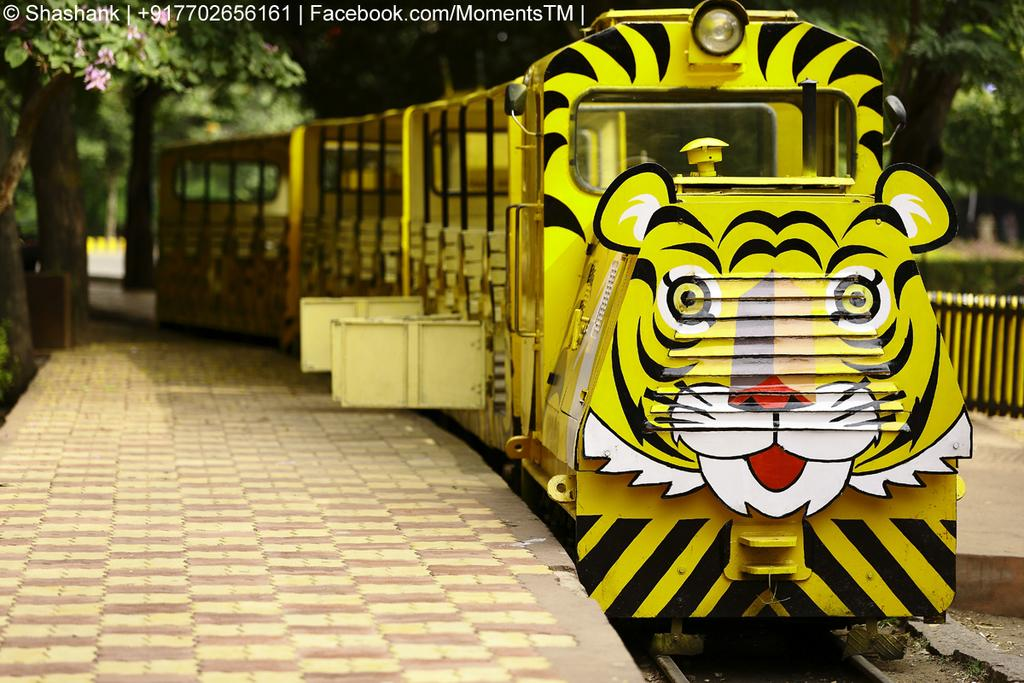What is the main subject of the image? The main subject of the image is a train on the track. What can be seen on both sides of the track? There is pavement on both sides of the track. What type of vegetation is visible in the image? There are trees visible in the image. What other objects can be seen in the image? There is a fence and flowers in the image. Is there any lighting source visible in the image? Yes, there is a light hanging from a tree in the image. What time is the bubble floating in the bedroom in the image? There is no bubble or bedroom present in the image; it features a train on a track with surrounding elements. 